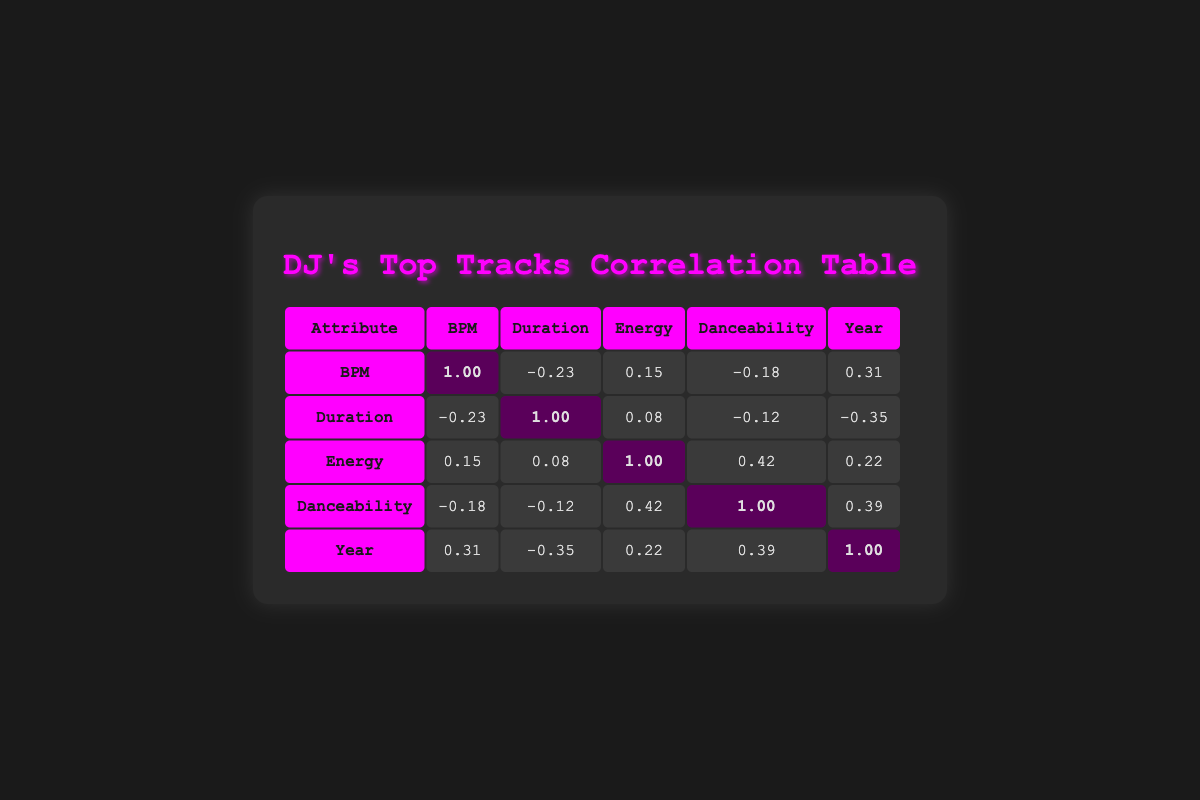What is the correlation value between BPM and Danceability? Looking at the table, the correlation value for BPM and Danceability is -0.18.
Answer: -0.18 Which attribute has the strongest positive correlation with Energy? The correlation value for Danceability and Energy is 0.42, which is the highest among the values related to Energy.
Answer: 0.42 What is the average correlation of Year with other attributes? To find the average, we take the correlation values with Year: 0.31, -0.35, 0.22, 0.39. So, the sum is 0.31 - 0.35 + 0.22 + 0.39 = 0.57. Dividing by the number of correlations (4) gives us 0.57 / 4 = 0.1425.
Answer: 0.1425 Is there a negative correlation between Duration and BPM? Yes, the correlation value between Duration and BPM is -0.23, which indicates a negative correlation.
Answer: Yes What is the combined correlation value of Energy and Year? The correlation values for Energy and Year are 0.22 and 0.39, respectively. Adding these gives 0.22 + 0.39 = 0.61, which indicates a positive correlation.
Answer: 0.61 Which attributes have a positive correlation with Year? Looking at the table, Year has a positive correlation with BPM (0.31), Energy (0.22), and Danceability (0.39).
Answer: BPM, Energy, Danceability What is the correlation value between Duration and Energy? The correlation value between Duration and Energy is 0.08.
Answer: 0.08 Does Danceability have a stronger correlation with Year than with BPM? Yes, Danceability’s correlation with Year is 0.39, which is stronger than its correlation with BPM, which is -0.18.
Answer: Yes What is the difference in correlation values between Energy and Duration? The correlation value for Energy is 1.00 and for Duration is 1.00. Taking the difference, we have 1.00 - 0.08 = 0.92.
Answer: 0.92 